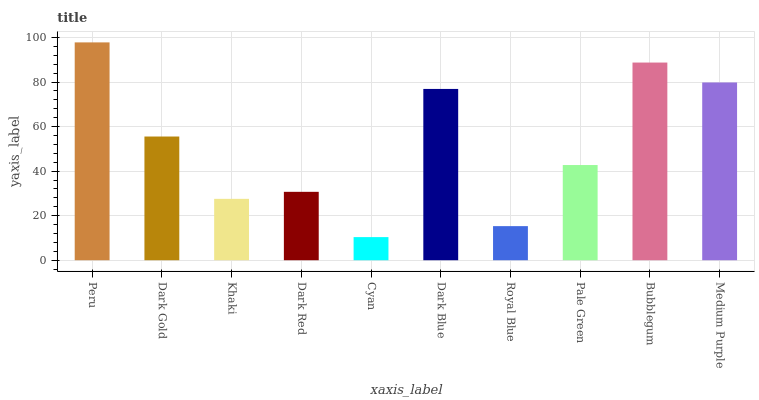Is Cyan the minimum?
Answer yes or no. Yes. Is Peru the maximum?
Answer yes or no. Yes. Is Dark Gold the minimum?
Answer yes or no. No. Is Dark Gold the maximum?
Answer yes or no. No. Is Peru greater than Dark Gold?
Answer yes or no. Yes. Is Dark Gold less than Peru?
Answer yes or no. Yes. Is Dark Gold greater than Peru?
Answer yes or no. No. Is Peru less than Dark Gold?
Answer yes or no. No. Is Dark Gold the high median?
Answer yes or no. Yes. Is Pale Green the low median?
Answer yes or no. Yes. Is Bubblegum the high median?
Answer yes or no. No. Is Royal Blue the low median?
Answer yes or no. No. 